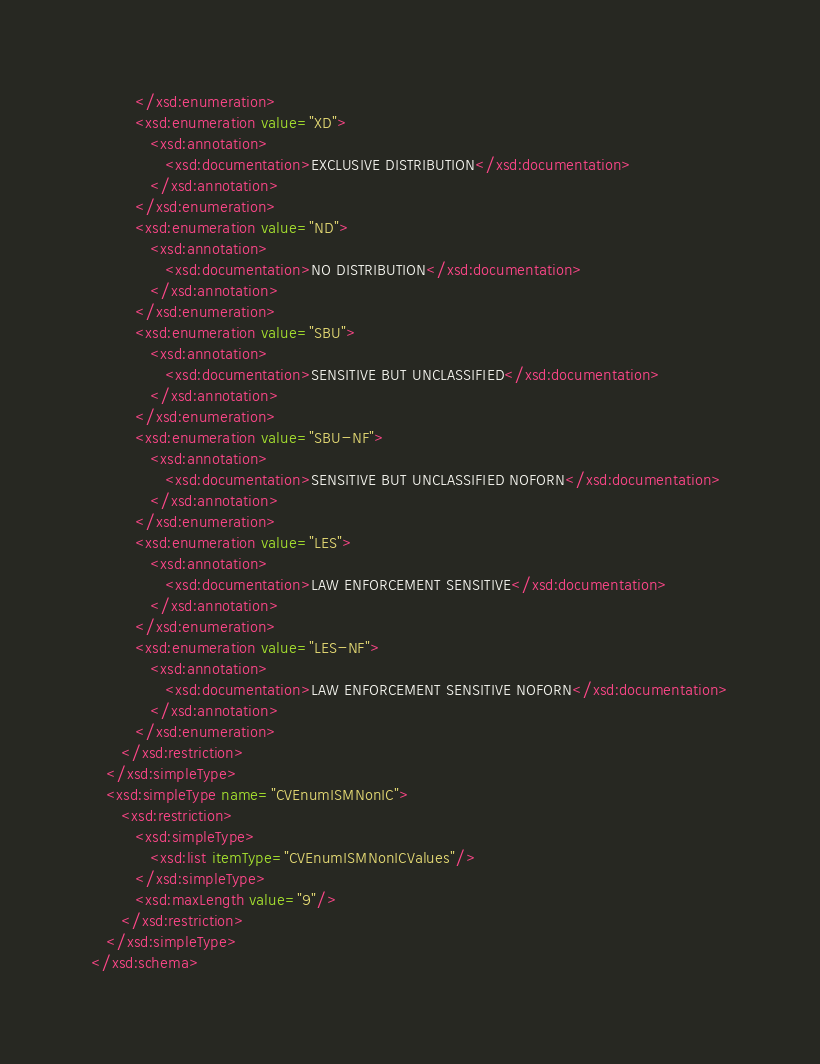Convert code to text. <code><loc_0><loc_0><loc_500><loc_500><_XML_>         </xsd:enumeration>
         <xsd:enumeration value="XD">
            <xsd:annotation>
               <xsd:documentation>EXCLUSIVE DISTRIBUTION</xsd:documentation>
            </xsd:annotation>
         </xsd:enumeration>
         <xsd:enumeration value="ND">
            <xsd:annotation>
               <xsd:documentation>NO DISTRIBUTION</xsd:documentation>
            </xsd:annotation>
         </xsd:enumeration>
         <xsd:enumeration value="SBU">
            <xsd:annotation>
               <xsd:documentation>SENSITIVE BUT UNCLASSIFIED</xsd:documentation>
            </xsd:annotation>
         </xsd:enumeration>
         <xsd:enumeration value="SBU-NF">
            <xsd:annotation>
               <xsd:documentation>SENSITIVE BUT UNCLASSIFIED NOFORN</xsd:documentation>
            </xsd:annotation>
         </xsd:enumeration>
         <xsd:enumeration value="LES">
            <xsd:annotation>
               <xsd:documentation>LAW ENFORCEMENT SENSITIVE</xsd:documentation>
            </xsd:annotation>
         </xsd:enumeration>
         <xsd:enumeration value="LES-NF">
            <xsd:annotation>
               <xsd:documentation>LAW ENFORCEMENT SENSITIVE NOFORN</xsd:documentation>
            </xsd:annotation>
         </xsd:enumeration>
      </xsd:restriction>
   </xsd:simpleType>
   <xsd:simpleType name="CVEnumISMNonIC">
      <xsd:restriction>
         <xsd:simpleType>
            <xsd:list itemType="CVEnumISMNonICValues"/>
         </xsd:simpleType>
         <xsd:maxLength value="9"/>
      </xsd:restriction>
   </xsd:simpleType>
</xsd:schema></code> 